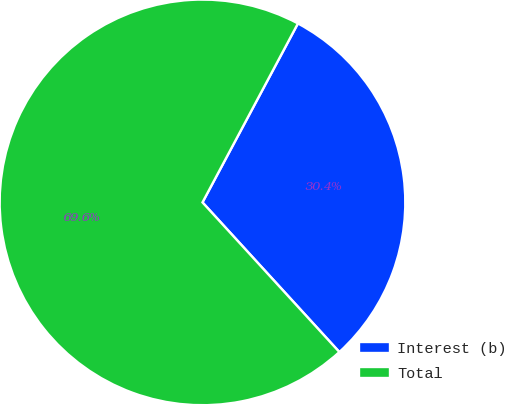Convert chart. <chart><loc_0><loc_0><loc_500><loc_500><pie_chart><fcel>Interest (b)<fcel>Total<nl><fcel>30.41%<fcel>69.59%<nl></chart> 